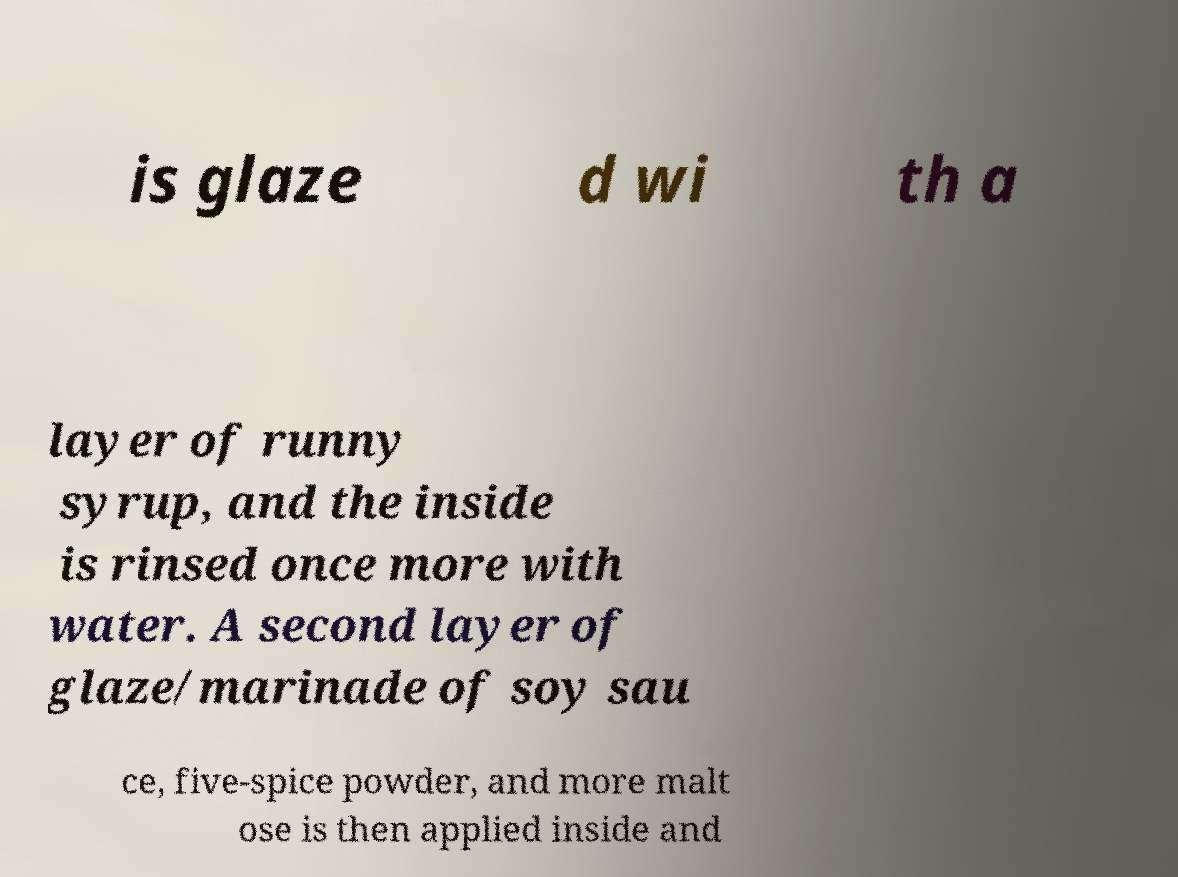Please identify and transcribe the text found in this image. is glaze d wi th a layer of runny syrup, and the inside is rinsed once more with water. A second layer of glaze/marinade of soy sau ce, five-spice powder, and more malt ose is then applied inside and 